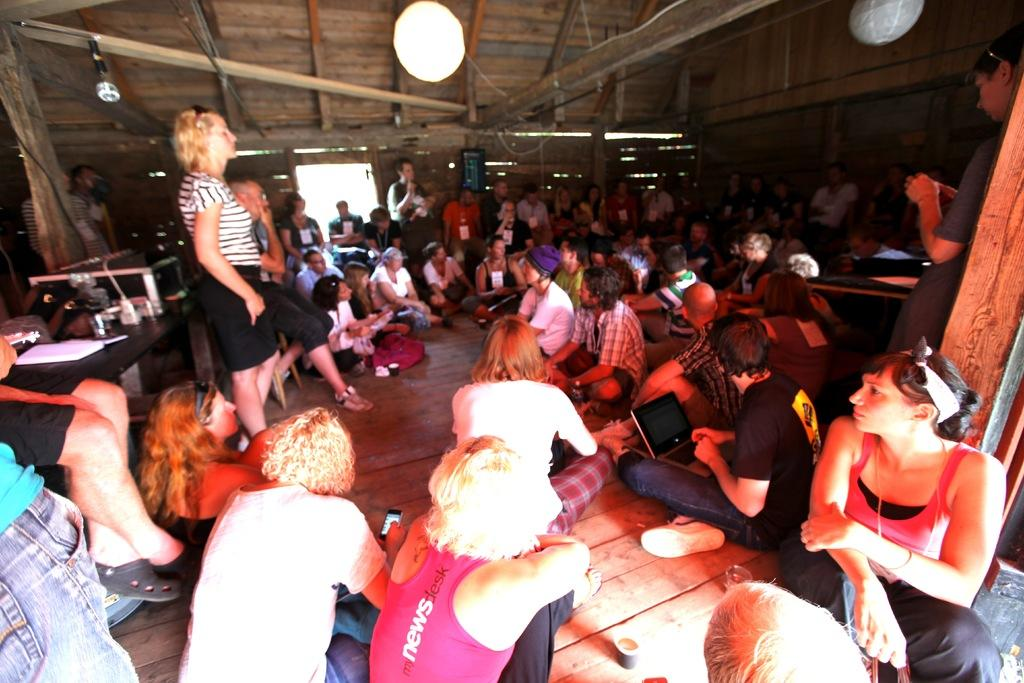How many people are in the image? There is a group of people in the image, but the exact number is not specified. What are some of the people in the image doing? Some people are sitting and some are standing in the image. What type of furniture is present in the image? There are tables in the image. What electronic device can be seen in the image? There is a laptop in the image. What type of reading material is present in the image? There is a book in the image. Are there any other objects visible in the image? Yes, there are other objects in the image. What type of quilt is being used as a desk in the image? There is no quilt or desk present in the image. How many mines are visible in the image? There are no mines present in the image. 